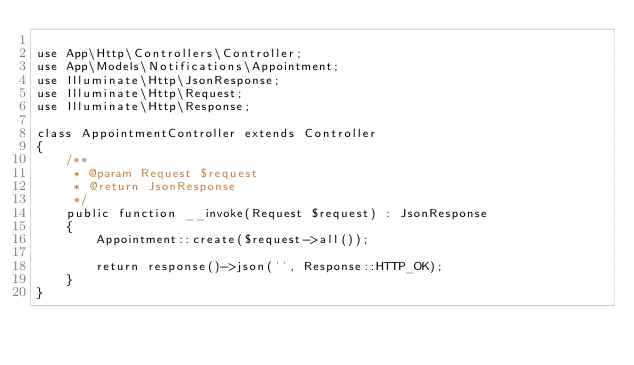<code> <loc_0><loc_0><loc_500><loc_500><_PHP_>
use App\Http\Controllers\Controller;
use App\Models\Notifications\Appointment;
use Illuminate\Http\JsonResponse;
use Illuminate\Http\Request;
use Illuminate\Http\Response;

class AppointmentController extends Controller
{
    /**
     * @param Request $request
     * @return JsonResponse
     */
    public function __invoke(Request $request) : JsonResponse
    {
        Appointment::create($request->all());

        return response()->json('', Response::HTTP_OK);
    }
}
</code> 